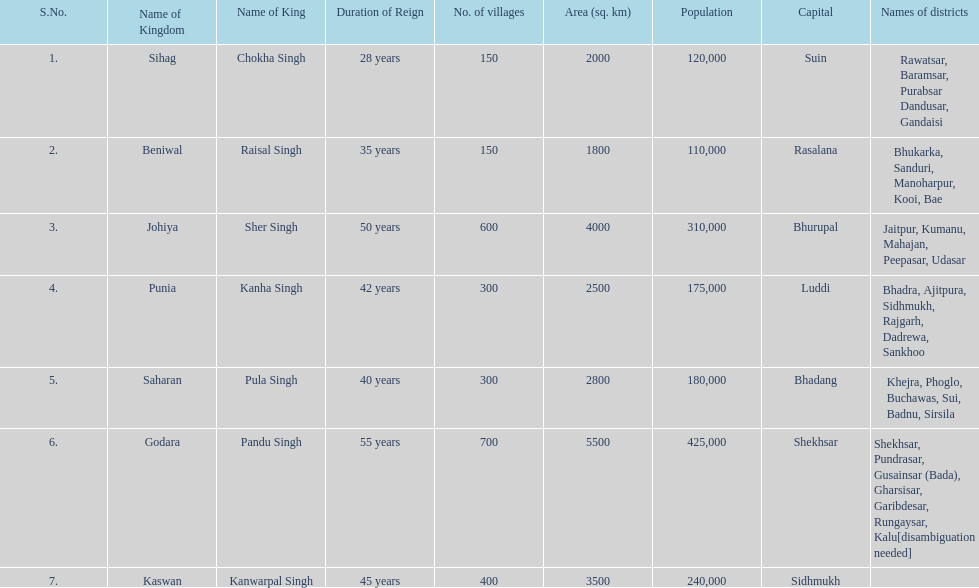What was the complete number of districts within the godara state? 7. 